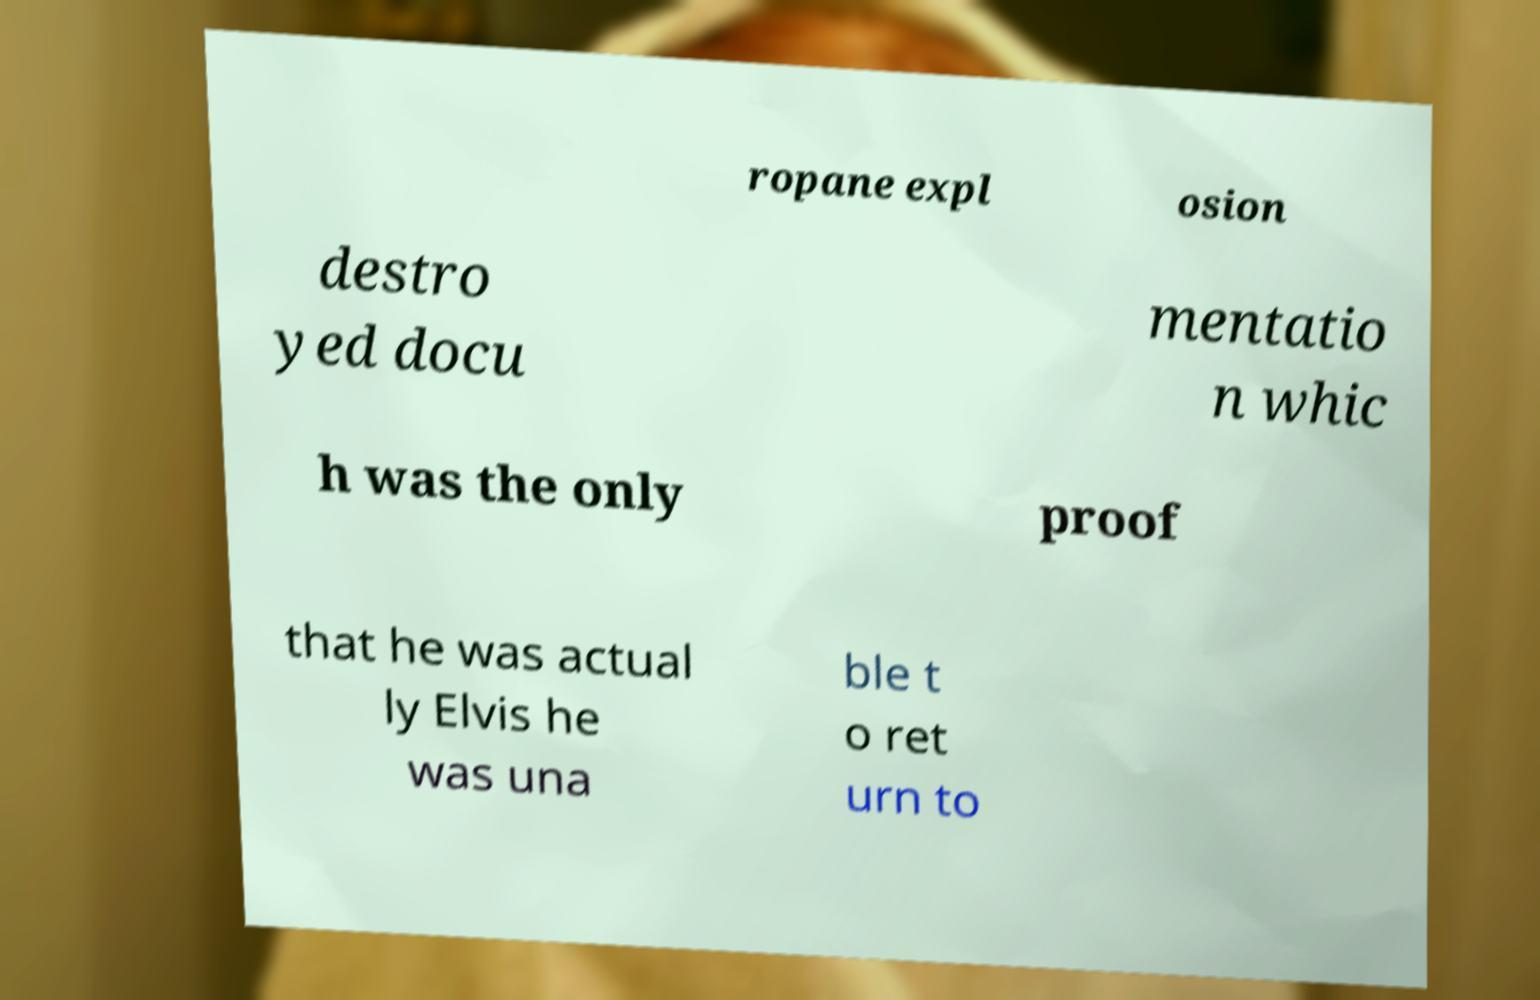Can you accurately transcribe the text from the provided image for me? ropane expl osion destro yed docu mentatio n whic h was the only proof that he was actual ly Elvis he was una ble t o ret urn to 